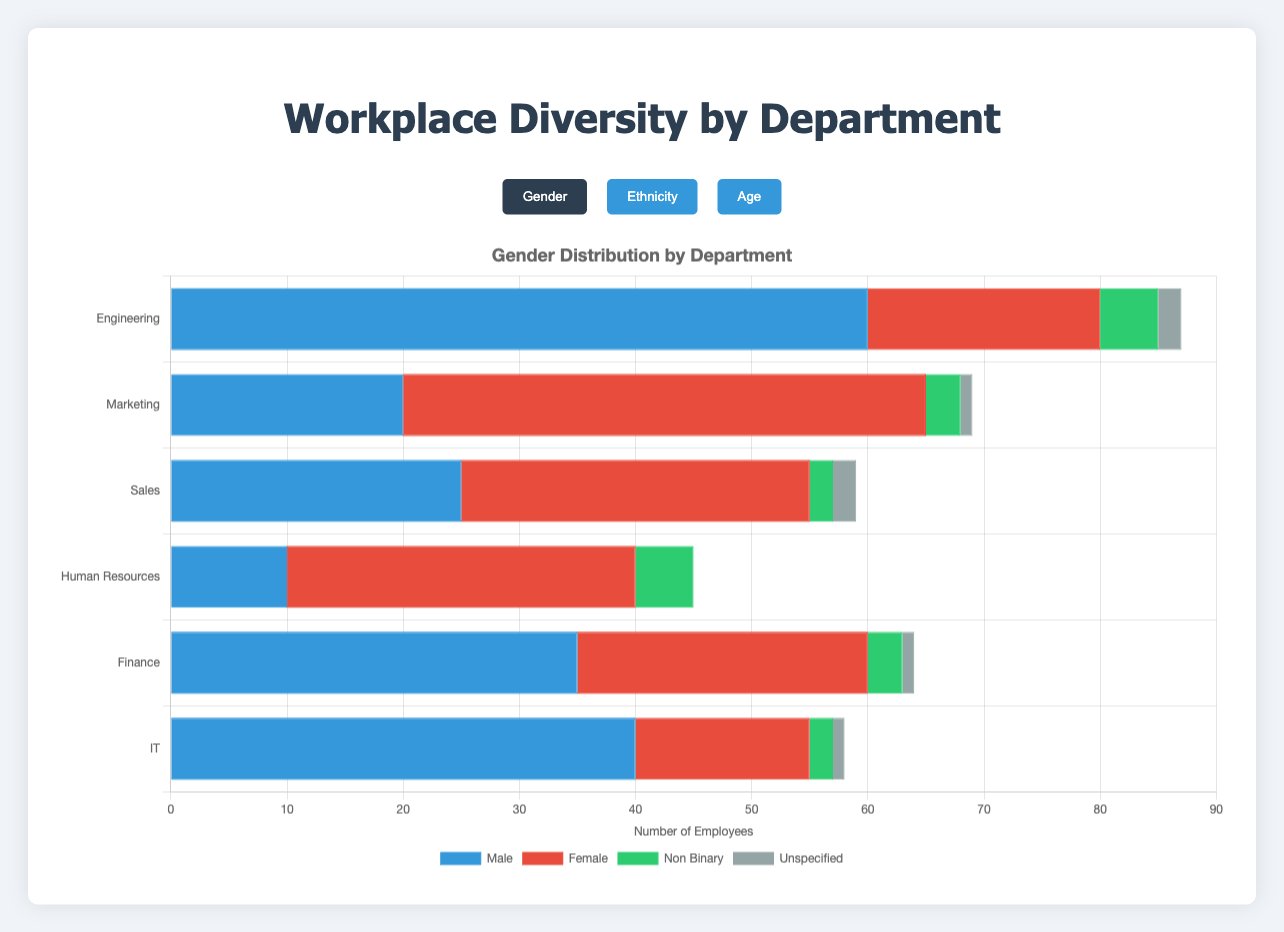Which department has the highest number of female employees? By looking at the 'Gender' category, the department with the highest number of female employees is Marketing, which has 45 female employees.
Answer: Marketing What is the total number of employees under the age of 25 in all departments combined? Summing up the 'under_25' values from all departments: 10 (Engineering) + 8 (Marketing) + 6 (Sales) + 4 (Human Resources) + 5 (Finance) + 4 (IT) = 37.
Answer: 37 Compare the number of male and female employees in the Finance department. Which is higher? In the Finance department, there are 35 male employees and 25 female employees. Therefore, the number of male employees is higher.
Answer: Male employees What is the average number of Asian employees per department? Summing up the 'Asian' values from all departments and dividing by the number of departments: (15 + 10 + 5 + 5 + 10 + 10) / 6 = 55 / 6 ≈ 9.17.
Answer: 9.17 Which department has the most diverse age distribution based on the number of different age groups represented? By counting non-zero age groups per department: Engineering (5), Marketing (5), Sales (5), Human Resources (5), Finance (5), IT (5). All departments have all five age groups represented equally.
Answer: All equal What is the sum of non-binary employees across all departments? Summing up the 'non_binary' values from all departments: 5 (Engineering) + 3 (Marketing) + 2 (Sales) + 5 (Human Resources) + 3 (Finance) + 2 (IT) = 20.
Answer: 20 Which department has the lowest number of Black or African American employees? By looking at the 'Ethnicity' category, the IT department has the lowest number of Black or African American employees, with 8.
Answer: IT Calculate the difference in the number of Hispanic or Latino employees between the Marketing and Finance departments. The Marketing department has 10 Hispanic or Latino employees, whereas the Finance department has 3. The difference is 10 - 3 = 7.
Answer: 7 Which gender has the highest representation in the IT department? By looking at the 'Gender' category for IT, the male gender has the highest representation with 40 employees.
Answer: Male What's the total number of employees in the Sales department? Summing up all the gender categories in the Sales department: 25 (male) + 30 (female) + 2 (non_binary) + 2 (unspecified) = 59.
Answer: 59 